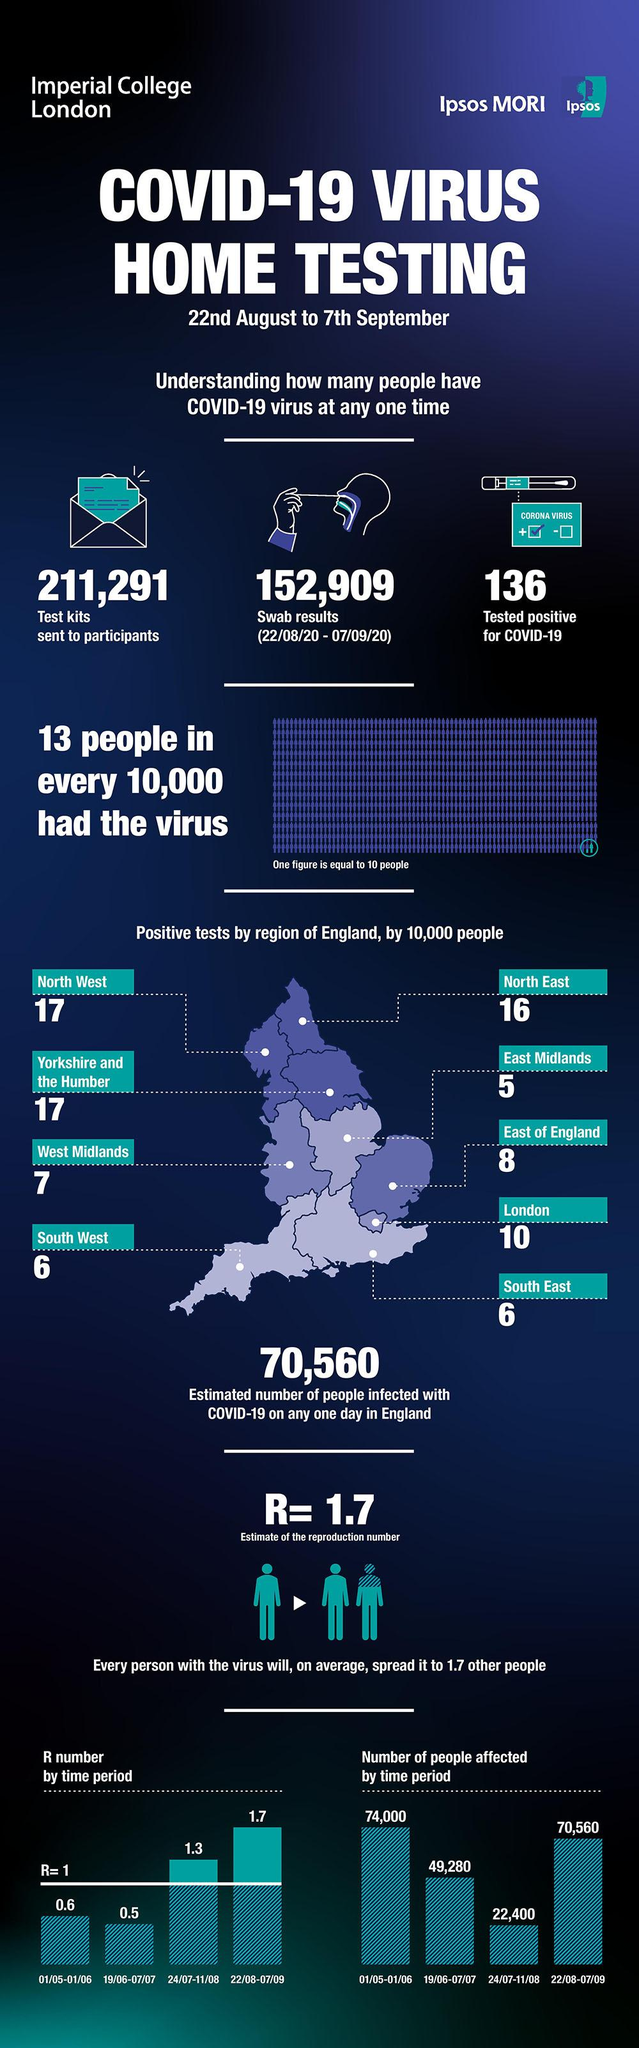Mention a couple of crucial points in this snapshot. In North West and North East combined, 33 positive tests were reported. The East Midlands region of England has reported five cases of the virus. In the North West region of England, the number of positive drug tests was higher than in the North East region. North West is not the only region in England with 17 positive tests, as Yorkshire and the Humber also has this number. There were six positive tests in the South West region. 